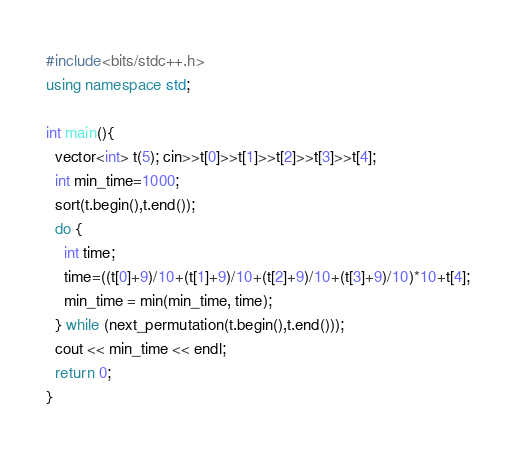Convert code to text. <code><loc_0><loc_0><loc_500><loc_500><_C++_>#include<bits/stdc++.h>
using namespace std;

int main(){
  vector<int> t(5); cin>>t[0]>>t[1]>>t[2]>>t[3]>>t[4];
  int min_time=1000;
  sort(t.begin(),t.end());
  do {
    int time;
    time=((t[0]+9)/10+(t[1]+9)/10+(t[2]+9)/10+(t[3]+9)/10)*10+t[4];
 	min_time = min(min_time, time); 
  } while (next_permutation(t.begin(),t.end()));
  cout << min_time << endl;
  return 0;
}
</code> 